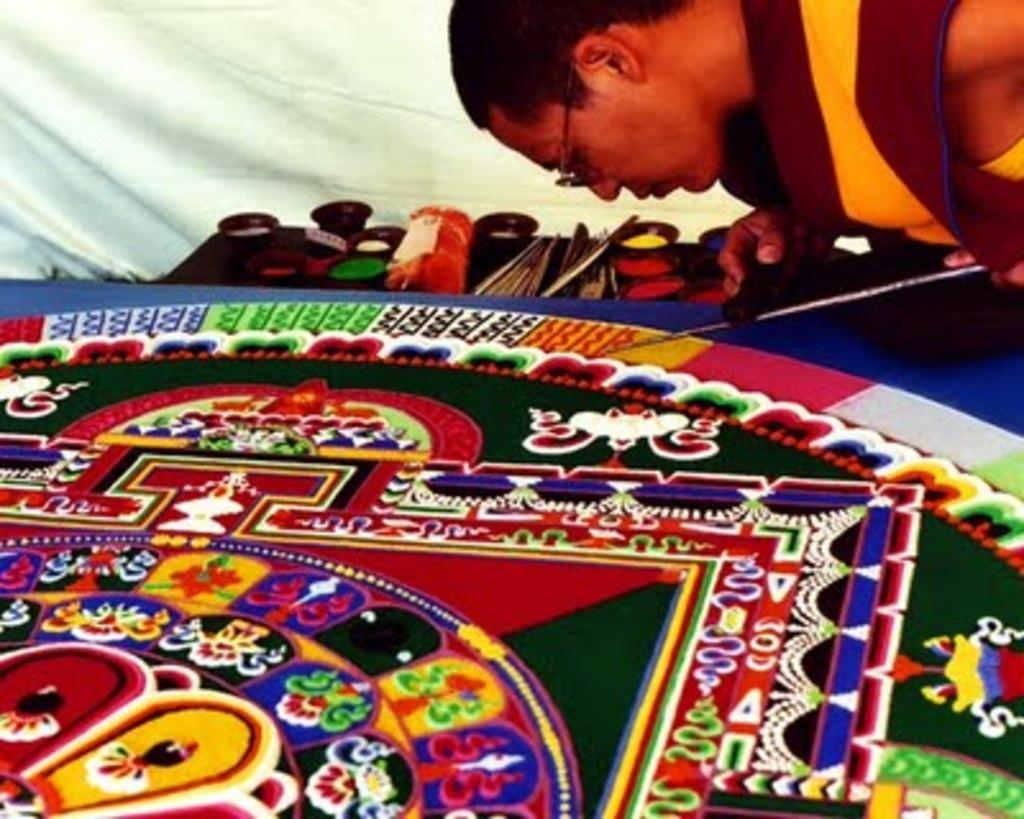Who is the person on the right side of the image? There is a man on the right side of the image. What is located at the bottom of the image? There is a painting at the bottom of the image. What tools can be seen in the background of the image? Brushes are visible in the background of the image. What type of containers are present in the background of the image? Cups are present in the background of the image. Can you tell me how many frogs are sitting on the cups in the image? There are no frogs present in the image; it features a man, a painting, brushes, and cups. Who is the owner of the painting in the image? The image does not provide information about the ownership of the painting. 